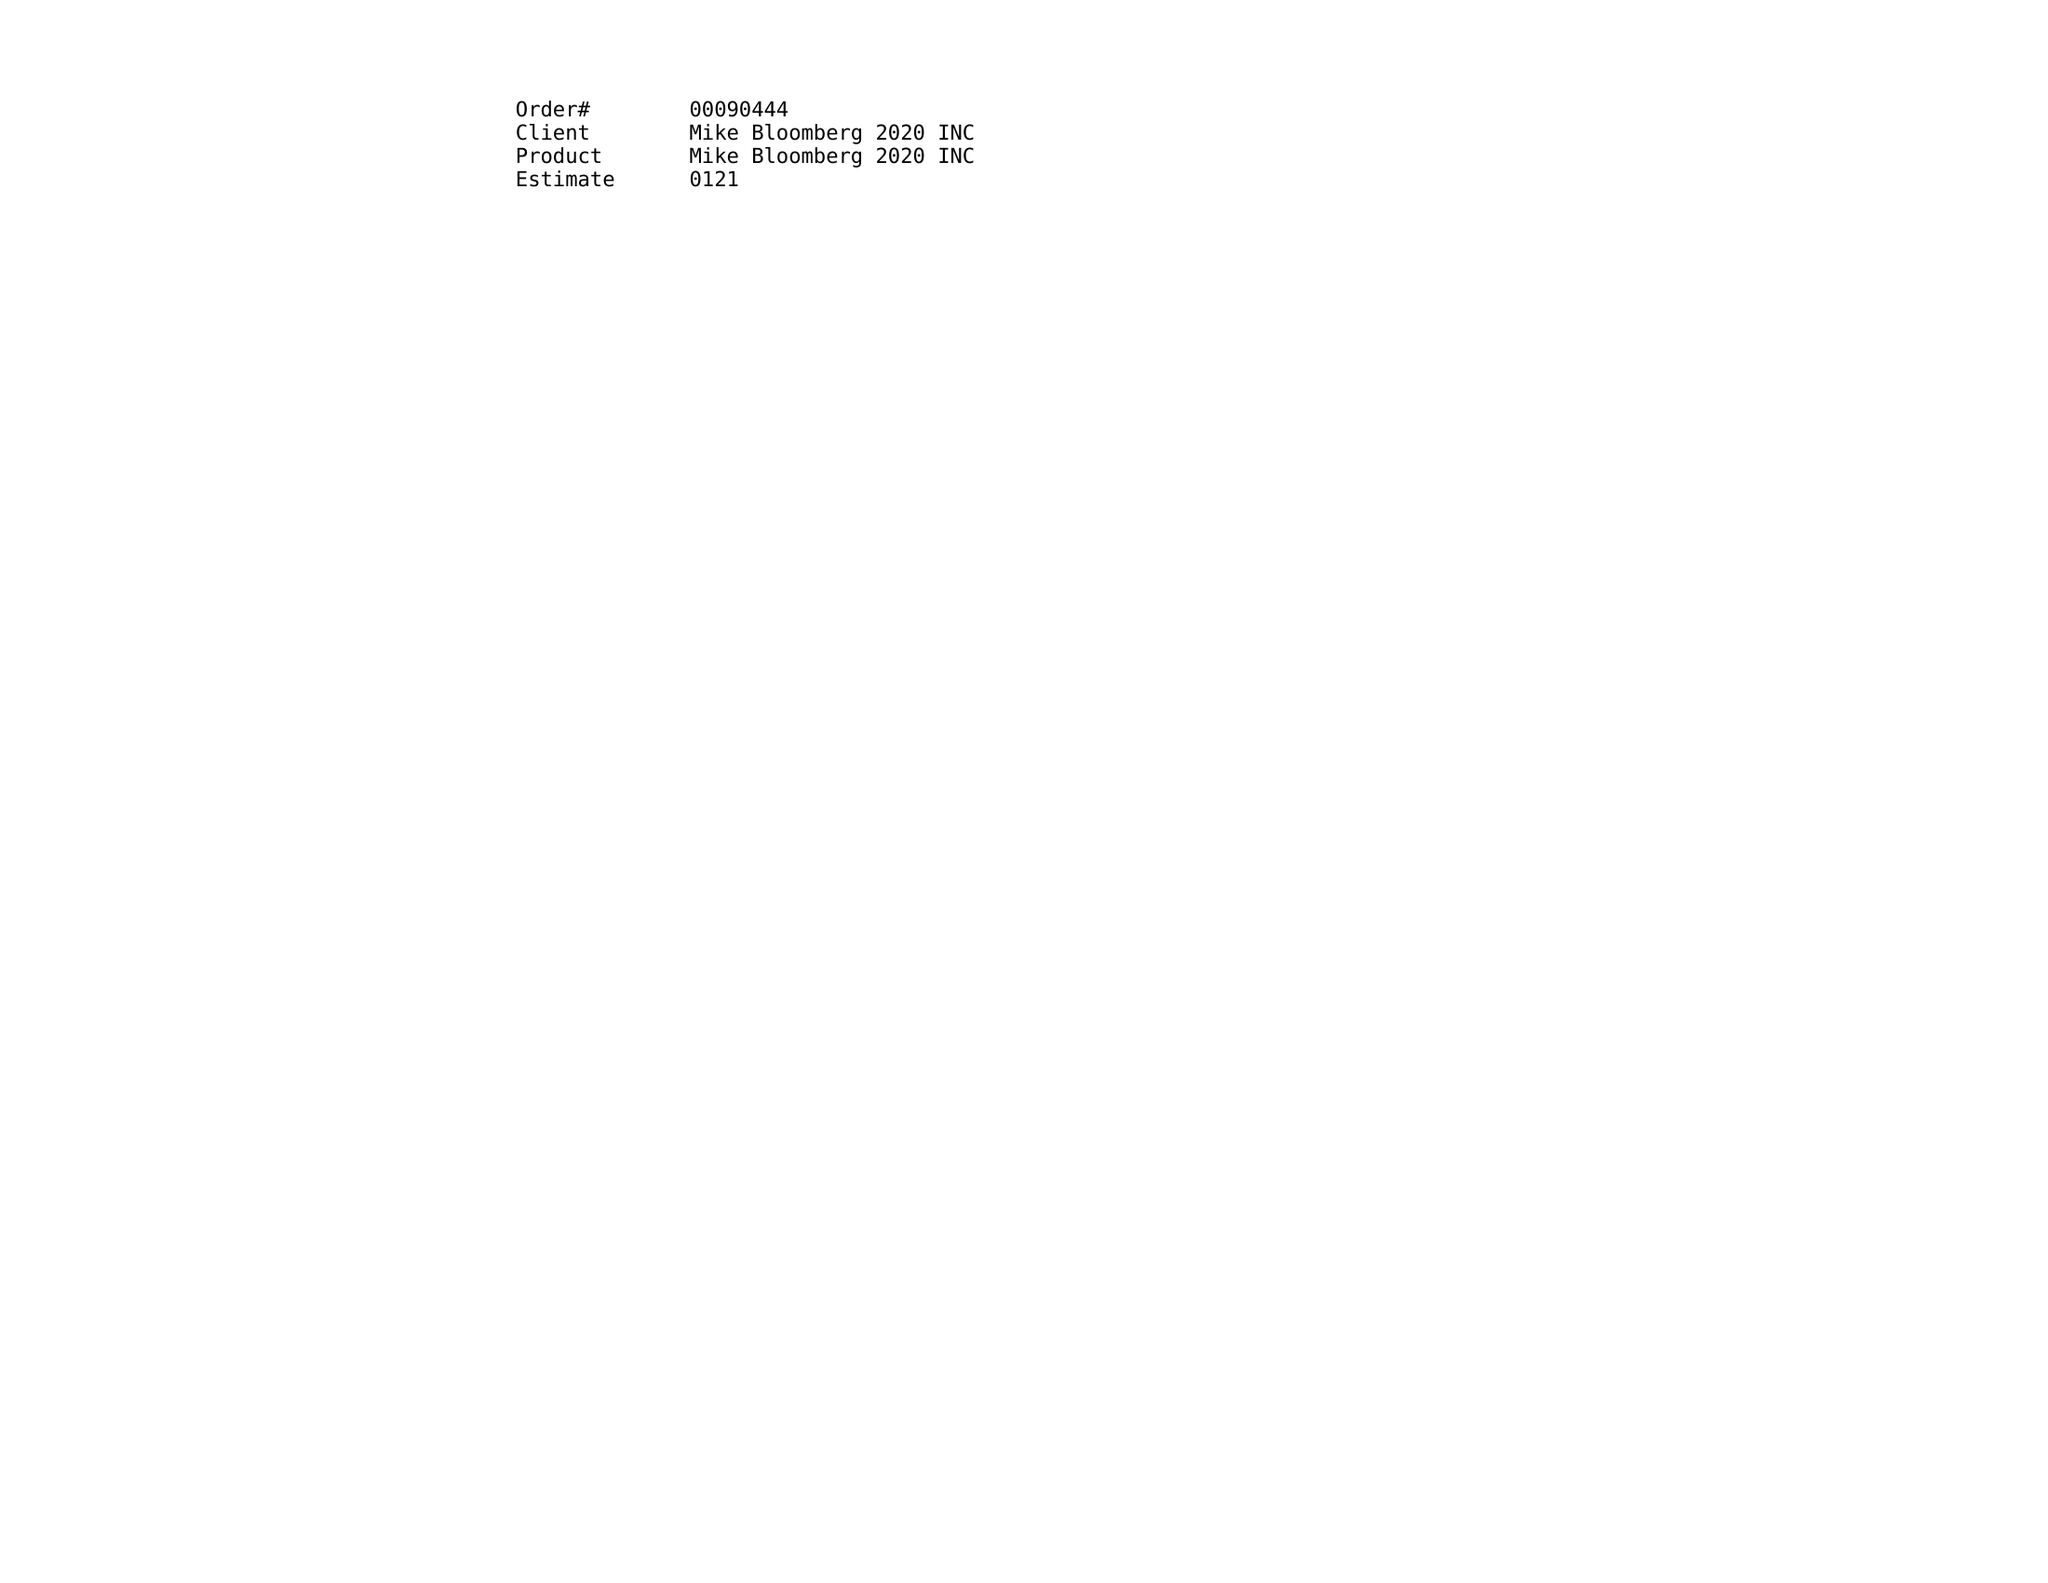What is the value for the flight_to?
Answer the question using a single word or phrase. 03/29/20 